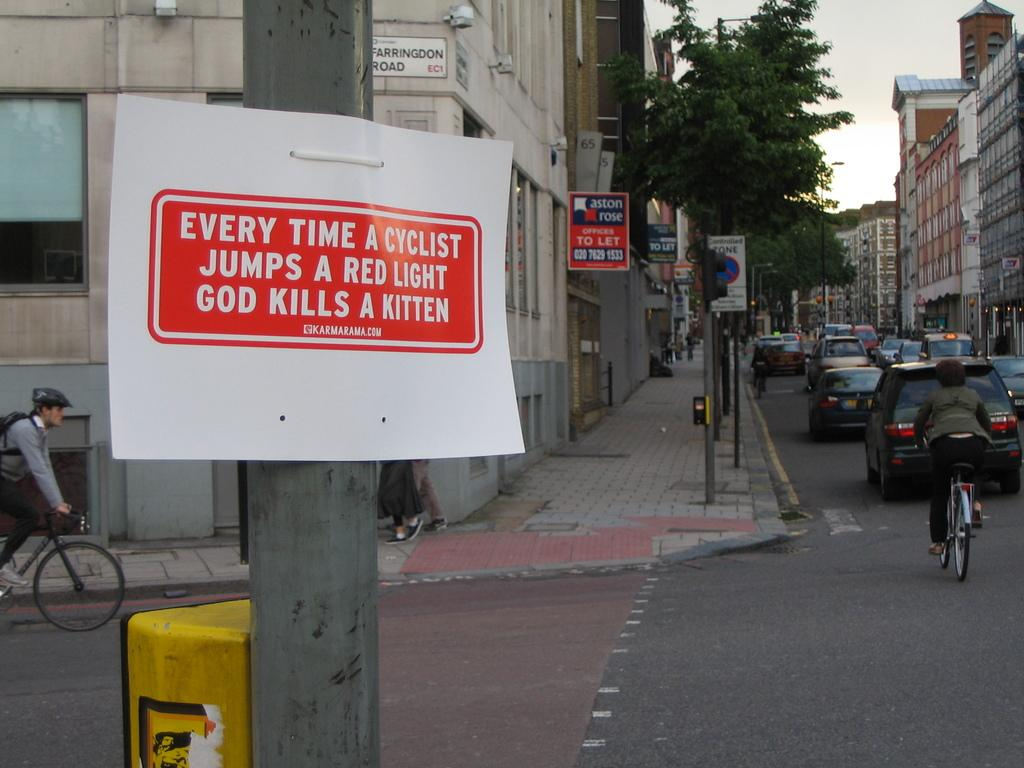Provide a one-sentence caption for the provided image. A sign on a pole says "Every time a cyclist jumps a red light God kills a kitten.". 